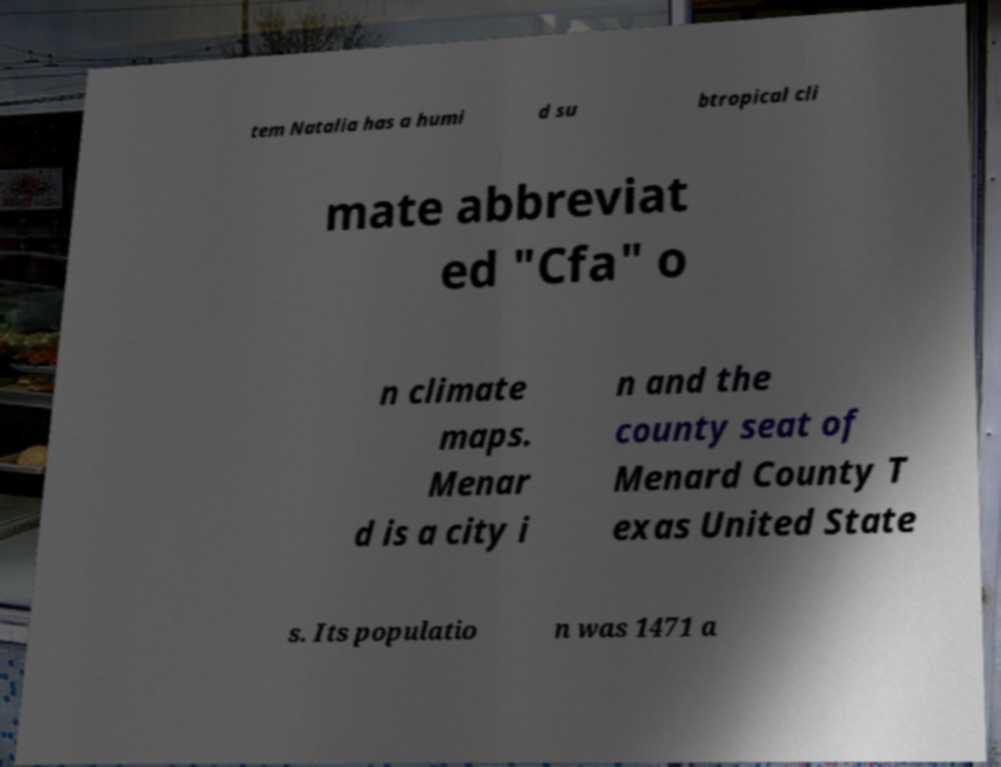For documentation purposes, I need the text within this image transcribed. Could you provide that? tem Natalia has a humi d su btropical cli mate abbreviat ed "Cfa" o n climate maps. Menar d is a city i n and the county seat of Menard County T exas United State s. Its populatio n was 1471 a 